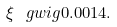<formula> <loc_0><loc_0><loc_500><loc_500>\xi \ g w i g 0 . 0 0 1 4 .</formula> 